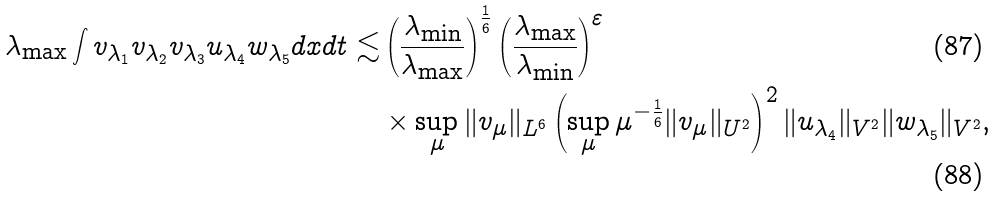Convert formula to latex. <formula><loc_0><loc_0><loc_500><loc_500>\lambda _ { \max } \int v _ { \lambda _ { 1 } } v _ { \lambda _ { 2 } } v _ { \lambda _ { 3 } } u _ { \lambda _ { 4 } } w _ { \lambda _ { 5 } } d x d t \lesssim & \left ( \frac { \lambda _ { \min } } { \lambda _ { \max } } \right ) ^ { \frac { 1 } { 6 } } \left ( \frac { \lambda _ { \max } } { \lambda _ { \min } } \right ) ^ { \varepsilon } \\ & \times \sup _ { \mu } \| v _ { \mu } \| _ { L ^ { 6 } } \left ( \sup _ { \mu } \mu ^ { - \frac { 1 } { 6 } } \| v _ { \mu } \| _ { U ^ { 2 } } \right ) ^ { 2 } \| u _ { \lambda _ { 4 } } \| _ { V ^ { 2 } } \| w _ { \lambda _ { 5 } } \| _ { V ^ { 2 } } ,</formula> 